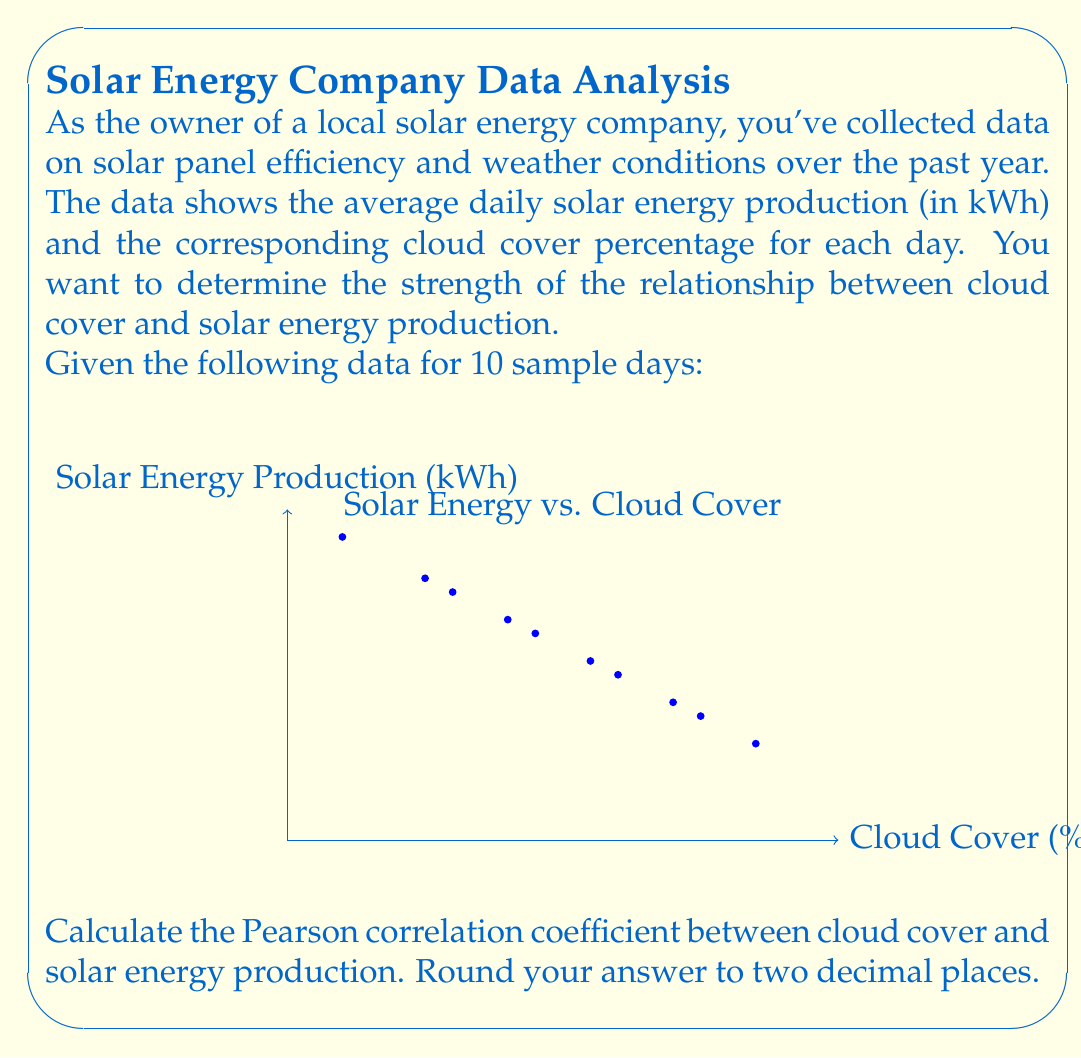Could you help me with this problem? To calculate the Pearson correlation coefficient (r), we'll use the formula:

$$ r = \frac{\sum_{i=1}^{n} (x_i - \bar{x})(y_i - \bar{y})}{\sqrt{\sum_{i=1}^{n} (x_i - \bar{x})^2 \sum_{i=1}^{n} (y_i - \bar{y})^2}} $$

Where:
$x_i$ = cloud cover percentage
$y_i$ = solar energy production
$\bar{x}$ = mean of cloud cover percentages
$\bar{y}$ = mean of solar energy production values
$n$ = number of data points (10 in this case)

Step 1: Calculate means
$\bar{x} = \frac{10 + 25 + 40 + 55 + 70 + 85 + 30 + 45 + 60 + 75}{10} = 49.5$
$\bar{y} = \frac{22 + 19 + 16 + 13 + 10 + 7 + 18 + 15 + 12 + 9}{10} = 14.1$

Step 2: Calculate $(x_i - \bar{x})$, $(y_i - \bar{y})$, $(x_i - \bar{x})^2$, $(y_i - \bar{y})^2$, and $(x_i - \bar{x})(y_i - \bar{y})$ for each data point.

Step 3: Sum up the values calculated in Step 2:
$\sum (x_i - \bar{x})(y_i - \bar{y}) = -1829.5$
$\sum (x_i - \bar{x})^2 = 5512.25$
$\sum (y_i - \bar{y})^2 = 222.9$

Step 4: Apply the formula:

$$ r = \frac{-1829.5}{\sqrt{5512.25 \times 222.9}} = -0.9815 $$

Step 5: Round to two decimal places: -0.98
Answer: -0.98 